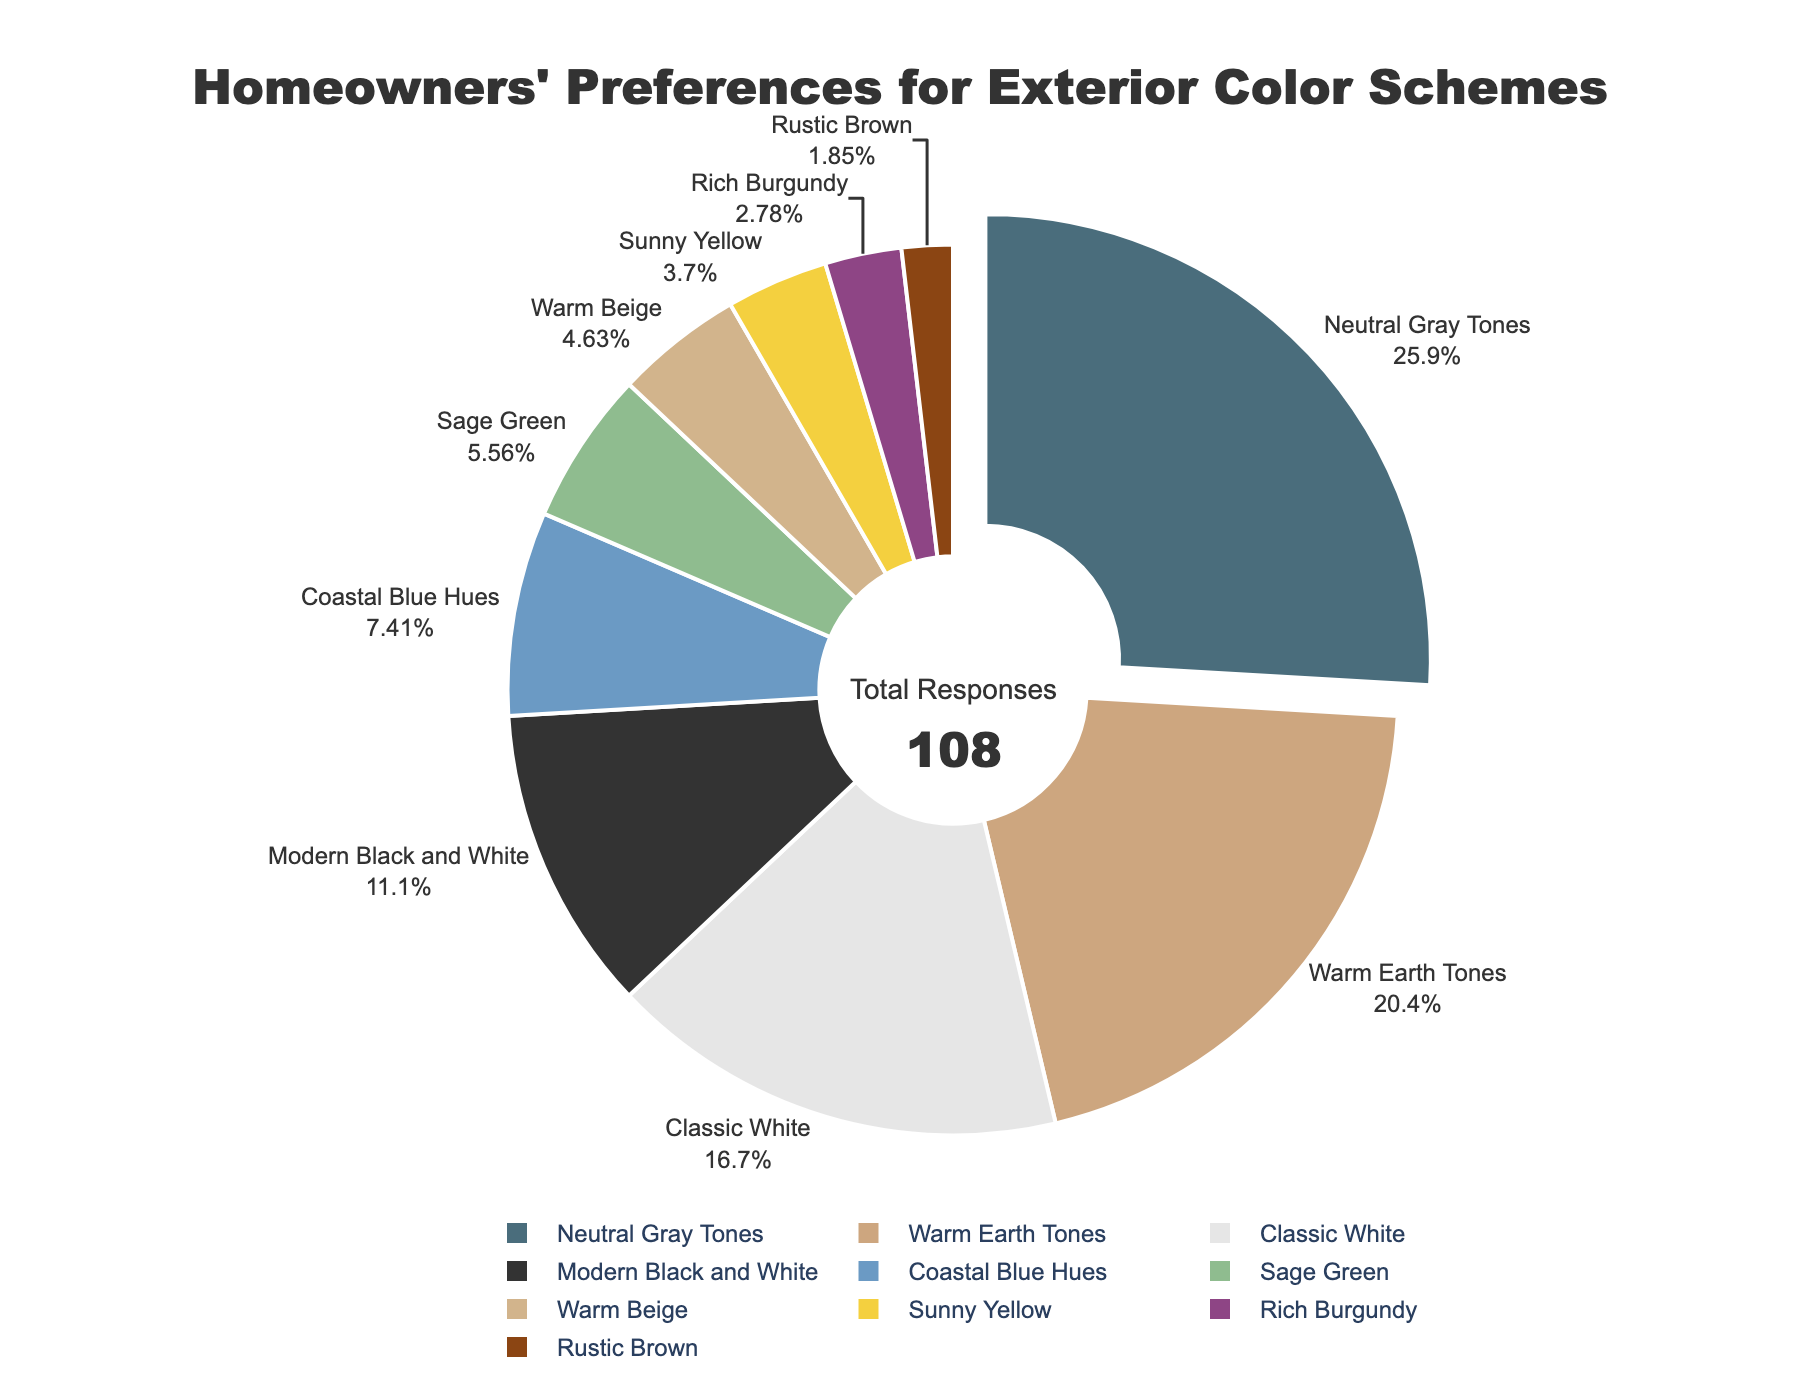What percentage of homeowners prefer Neutral Gray Tones? Neutral Gray Tones is one of the color schemes listed on the chart, and the percentage associated with it is 28%.
Answer: 28% What is the total percentage of homeowners that prefer either Neutral Gray Tones or Warm Earth Tones? First, find the percentage for each of the two color schemes: Neutral Gray Tones (28%) and Warm Earth Tones (22%). Add these two percentages together: 28 + 22 = 50%.
Answer: 50% Between Classic White and Modern Black and White, which color scheme do more homeowners prefer? Compare the percentages given for Classic White and Modern Black and White. Classic White has 18% while Modern Black and White has 12%. Since 18% is greater than 12%, more homeowners prefer Classic White.
Answer: Classic White Which color scheme has the lowest percentage of preference among homeowners? Look at the list of percentages for each color scheme and find the smallest value. The smallest percentage is 2% which corresponds to Rustic Brown.
Answer: Rustic Brown What is the combined percentage of homeowners preferring Coastal Blue Hues, Sage Green, and Warm Beige? Sum the percentages of Coastal Blue Hues (8%), Sage Green (6%), and Warm Beige (5%): 8 + 6 + 5 = 19%.
Answer: 19% What is the difference in preference between the most popular and the least popular color schemes? Identify the most popular (Neutral Gray Tones at 28%) and the least popular (Rustic Brown at 2%) color schemes. Calculate the difference: 28 - 2 = 26%.
Answer: 26% How do the preferences for Sage Green and Sunny Yellow compare? Find the percentages for Sage Green (6%) and Sunny Yellow (4%). Since 6% is greater than 4%, more homeowners prefer Sage Green over Sunny Yellow.
Answer: Sage Green What color schemes fall below a 10% preference rate among homeowners? Identify the color schemes with percentages less than 10%: Modern Black and White (12%), Coastal Blue Hues (8%), Sage Green (6%), Warm Beige (5%), Sunny Yellow (4%), Rich Burgundy (3%), and Rustic Brown (2%). Exclude the one above 10%.
Answer: Coastal Blue Hues, Sage Green, Warm Beige, Sunny Yellow, Rich Burgundy, Rustic Brown What color represents the Warm Earth Tones on the pie chart? To answer this, locate the color scheme "Warm Earth Tones" and note its corresponding color in the chart legend; it is identified by a warm Earth tone color.
Answer: Warm Earth Tones is represented by the color associated with its segment Compare the sum of preferences for color schemes classified under earth tones (Warm Earth Tones, Sage Green, Warm Beige, Rustic Brown) to the sum of preferences for classic tones (Classic White, Neutral Gray Tones). Which group has higher preference? Sum the percentages for earth tones (Warm Earth Tones: 22%, Sage Green: 6%, Warm Beige: 5%, Rustic Brown: 2%) and classic tones (Classic White: 18%, Neutral Gray Tones: 28%): Earth Tones = 22+6+5+2 = 35%; Classic Tones = 18+28 = 46%. Compare these sums: 46% is greater than 35%.
Answer: Classic tones have higher preference 